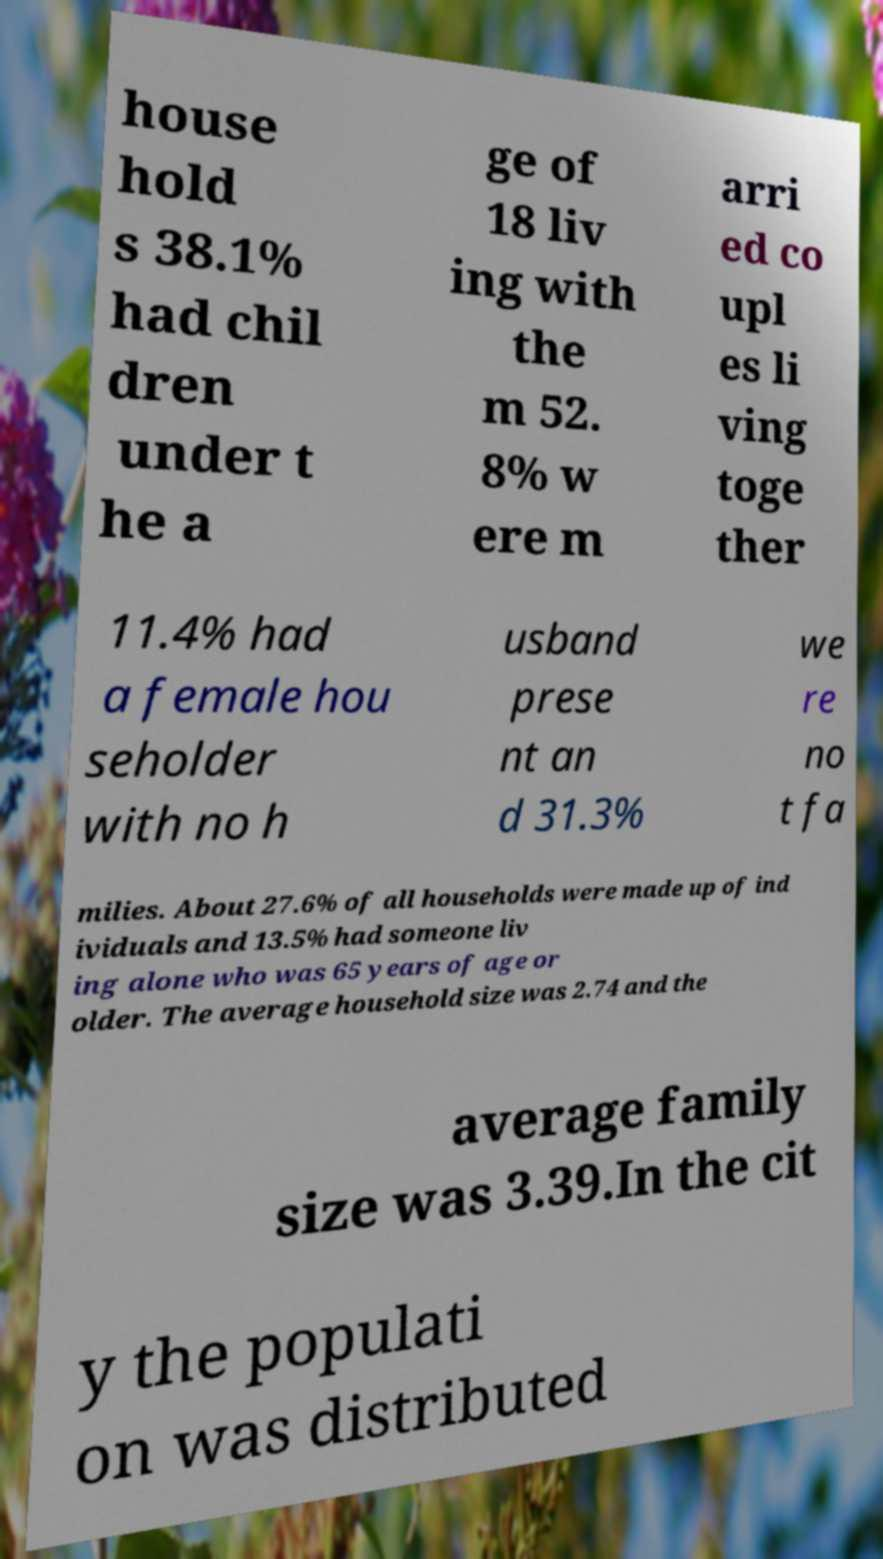There's text embedded in this image that I need extracted. Can you transcribe it verbatim? house hold s 38.1% had chil dren under t he a ge of 18 liv ing with the m 52. 8% w ere m arri ed co upl es li ving toge ther 11.4% had a female hou seholder with no h usband prese nt an d 31.3% we re no t fa milies. About 27.6% of all households were made up of ind ividuals and 13.5% had someone liv ing alone who was 65 years of age or older. The average household size was 2.74 and the average family size was 3.39.In the cit y the populati on was distributed 